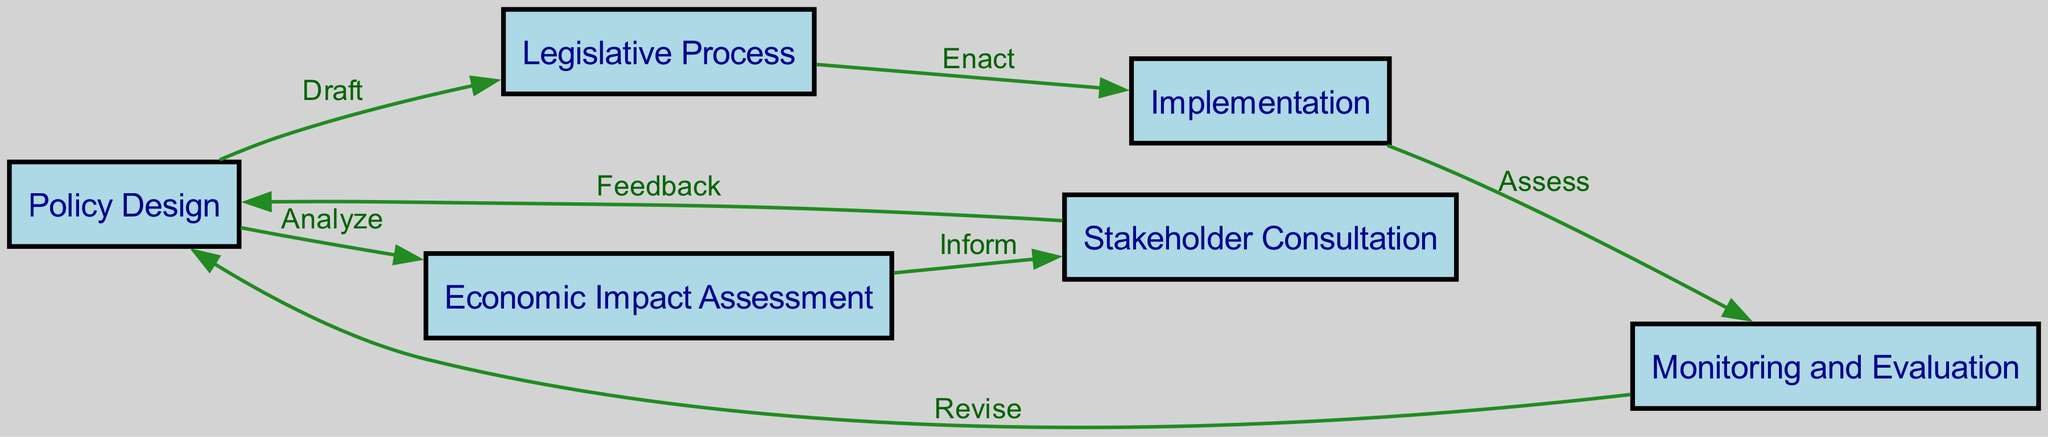What is the first step in the carbon pricing policy implementation flow? The first step in the flow is labeled "Policy Design", which is indicated as the starting node in the diagram.
Answer: Policy Design How many nodes are in the diagram? Counting the nodes listed in the diagram, there are six nodes: Policy Design, Economic Impact Assessment, Stakeholder Consultation, Legislative Process, Implementation, and Monitoring and Evaluation.
Answer: Six What is the relationship between Policy Design and Economic Impact Assessment? The diagram shows an edge labeled "Analyze" connecting Policy Design to Economic Impact Assessment, indicating that Policy Design is analyzed to inform Economic Impact Assessment.
Answer: Analyze Which step follows Legislative Process? According to the edges in the diagram, after Legislative Process, the next step is Implementation, which is connected by the edge labeled "Enact".
Answer: Implementation What feedback loop exists in the diagram? The diagram includes a feedback loop between Stakeholder Consultation and Policy Design, where Stakeholder Consultation provides feedback that informs subsequent Policy Design.
Answer: Feedback What action is taken after Implementation? After Implementation, the action taken is Monitoring and Evaluation, as per the edge labeled "Assess" connecting Implementation to Monitoring and Evaluation.
Answer: Monitoring and Evaluation Which step revises the policy based on evaluation? The step that revises the policy based on evaluation is Policy Design, which is linked back from Monitoring and Evaluation with the edge labeled "Revise".
Answer: Policy Design How many edges are there in the diagram? By counting the connections (edges) between the nodes, we find that there are seven edges that map the relationships in the implementation flow.
Answer: Seven What process is informed by Economic Impact Assessment? Stakeholder Consultation is informed by Economic Impact Assessment, as indicated by the edge labeled "Inform" connecting these two nodes.
Answer: Stakeholder Consultation 